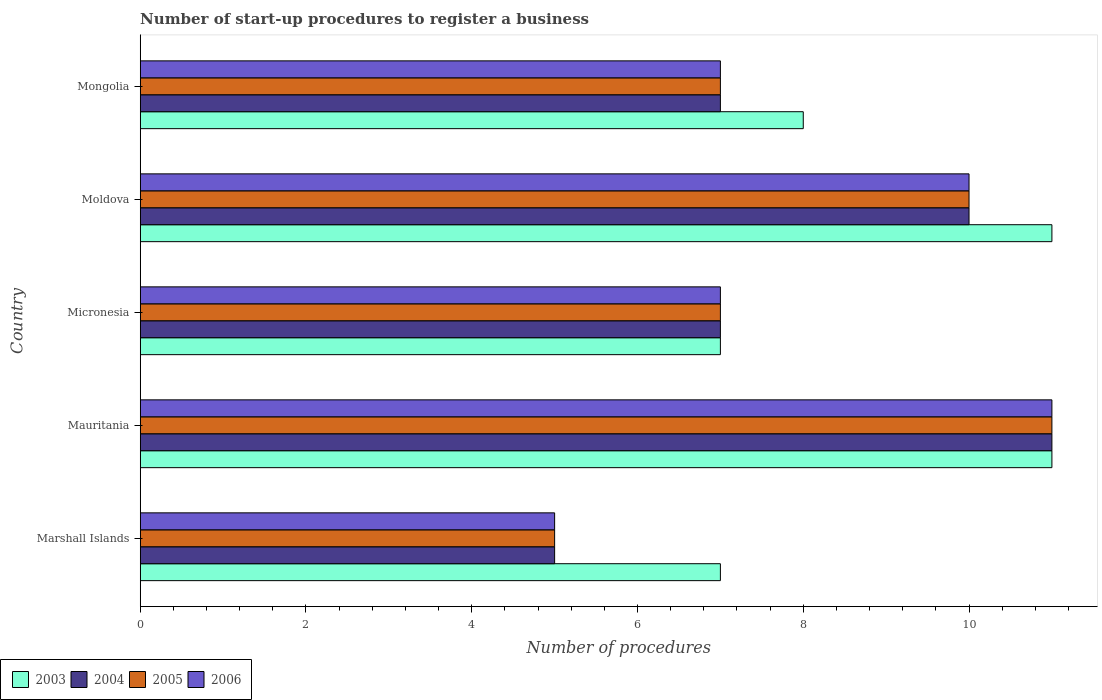How many different coloured bars are there?
Your answer should be compact. 4. Are the number of bars on each tick of the Y-axis equal?
Offer a terse response. Yes. How many bars are there on the 4th tick from the top?
Keep it short and to the point. 4. How many bars are there on the 4th tick from the bottom?
Give a very brief answer. 4. What is the label of the 1st group of bars from the top?
Ensure brevity in your answer.  Mongolia. Across all countries, what is the minimum number of procedures required to register a business in 2003?
Offer a very short reply. 7. In which country was the number of procedures required to register a business in 2005 maximum?
Provide a short and direct response. Mauritania. In which country was the number of procedures required to register a business in 2005 minimum?
Your answer should be compact. Marshall Islands. What is the difference between the number of procedures required to register a business in 2004 in Marshall Islands and that in Mongolia?
Give a very brief answer. -2. What is the difference between the number of procedures required to register a business in 2006 in Mauritania and the number of procedures required to register a business in 2005 in Marshall Islands?
Your answer should be very brief. 6. What is the difference between the number of procedures required to register a business in 2004 and number of procedures required to register a business in 2005 in Moldova?
Ensure brevity in your answer.  0. What is the ratio of the number of procedures required to register a business in 2006 in Marshall Islands to that in Mongolia?
Make the answer very short. 0.71. Is the number of procedures required to register a business in 2004 in Mauritania less than that in Moldova?
Offer a terse response. No. Is the difference between the number of procedures required to register a business in 2004 in Mauritania and Micronesia greater than the difference between the number of procedures required to register a business in 2005 in Mauritania and Micronesia?
Offer a terse response. No. What is the difference between the highest and the lowest number of procedures required to register a business in 2006?
Provide a short and direct response. 6. In how many countries, is the number of procedures required to register a business in 2003 greater than the average number of procedures required to register a business in 2003 taken over all countries?
Make the answer very short. 2. What does the 3rd bar from the top in Micronesia represents?
Offer a terse response. 2004. Is it the case that in every country, the sum of the number of procedures required to register a business in 2004 and number of procedures required to register a business in 2003 is greater than the number of procedures required to register a business in 2005?
Your answer should be compact. Yes. Are all the bars in the graph horizontal?
Ensure brevity in your answer.  Yes. How many countries are there in the graph?
Keep it short and to the point. 5. What is the difference between two consecutive major ticks on the X-axis?
Ensure brevity in your answer.  2. Does the graph contain any zero values?
Your answer should be very brief. No. Does the graph contain grids?
Keep it short and to the point. No. What is the title of the graph?
Provide a short and direct response. Number of start-up procedures to register a business. What is the label or title of the X-axis?
Your answer should be very brief. Number of procedures. What is the Number of procedures of 2005 in Marshall Islands?
Give a very brief answer. 5. What is the Number of procedures in 2003 in Mauritania?
Give a very brief answer. 11. What is the Number of procedures in 2006 in Micronesia?
Provide a short and direct response. 7. What is the Number of procedures in 2005 in Moldova?
Offer a terse response. 10. What is the Number of procedures in 2006 in Moldova?
Offer a terse response. 10. Across all countries, what is the maximum Number of procedures of 2003?
Give a very brief answer. 11. Across all countries, what is the maximum Number of procedures of 2004?
Your response must be concise. 11. Across all countries, what is the minimum Number of procedures of 2006?
Make the answer very short. 5. What is the difference between the Number of procedures of 2003 in Marshall Islands and that in Mauritania?
Keep it short and to the point. -4. What is the difference between the Number of procedures of 2004 in Marshall Islands and that in Mauritania?
Provide a short and direct response. -6. What is the difference between the Number of procedures in 2005 in Marshall Islands and that in Mauritania?
Your answer should be very brief. -6. What is the difference between the Number of procedures in 2006 in Marshall Islands and that in Mauritania?
Keep it short and to the point. -6. What is the difference between the Number of procedures in 2004 in Marshall Islands and that in Micronesia?
Offer a terse response. -2. What is the difference between the Number of procedures in 2005 in Marshall Islands and that in Micronesia?
Offer a very short reply. -2. What is the difference between the Number of procedures in 2003 in Marshall Islands and that in Moldova?
Offer a very short reply. -4. What is the difference between the Number of procedures in 2005 in Marshall Islands and that in Moldova?
Your response must be concise. -5. What is the difference between the Number of procedures in 2006 in Marshall Islands and that in Moldova?
Give a very brief answer. -5. What is the difference between the Number of procedures in 2003 in Marshall Islands and that in Mongolia?
Ensure brevity in your answer.  -1. What is the difference between the Number of procedures of 2006 in Marshall Islands and that in Mongolia?
Give a very brief answer. -2. What is the difference between the Number of procedures in 2003 in Mauritania and that in Micronesia?
Offer a very short reply. 4. What is the difference between the Number of procedures in 2004 in Mauritania and that in Micronesia?
Your answer should be very brief. 4. What is the difference between the Number of procedures of 2006 in Mauritania and that in Micronesia?
Ensure brevity in your answer.  4. What is the difference between the Number of procedures of 2003 in Mauritania and that in Moldova?
Your answer should be very brief. 0. What is the difference between the Number of procedures in 2004 in Mauritania and that in Moldova?
Your answer should be compact. 1. What is the difference between the Number of procedures of 2005 in Mauritania and that in Mongolia?
Offer a very short reply. 4. What is the difference between the Number of procedures of 2006 in Mauritania and that in Mongolia?
Give a very brief answer. 4. What is the difference between the Number of procedures of 2004 in Micronesia and that in Moldova?
Offer a terse response. -3. What is the difference between the Number of procedures in 2006 in Micronesia and that in Moldova?
Give a very brief answer. -3. What is the difference between the Number of procedures in 2004 in Micronesia and that in Mongolia?
Provide a succinct answer. 0. What is the difference between the Number of procedures of 2005 in Micronesia and that in Mongolia?
Provide a short and direct response. 0. What is the difference between the Number of procedures of 2003 in Moldova and that in Mongolia?
Give a very brief answer. 3. What is the difference between the Number of procedures of 2005 in Moldova and that in Mongolia?
Provide a succinct answer. 3. What is the difference between the Number of procedures of 2003 in Marshall Islands and the Number of procedures of 2004 in Mauritania?
Ensure brevity in your answer.  -4. What is the difference between the Number of procedures in 2003 in Marshall Islands and the Number of procedures in 2005 in Mauritania?
Give a very brief answer. -4. What is the difference between the Number of procedures of 2003 in Marshall Islands and the Number of procedures of 2006 in Mauritania?
Your response must be concise. -4. What is the difference between the Number of procedures of 2004 in Marshall Islands and the Number of procedures of 2005 in Mauritania?
Make the answer very short. -6. What is the difference between the Number of procedures in 2004 in Marshall Islands and the Number of procedures in 2006 in Mauritania?
Provide a short and direct response. -6. What is the difference between the Number of procedures of 2003 in Marshall Islands and the Number of procedures of 2004 in Micronesia?
Ensure brevity in your answer.  0. What is the difference between the Number of procedures in 2003 in Marshall Islands and the Number of procedures in 2005 in Micronesia?
Offer a terse response. 0. What is the difference between the Number of procedures in 2004 in Marshall Islands and the Number of procedures in 2005 in Micronesia?
Offer a very short reply. -2. What is the difference between the Number of procedures in 2005 in Marshall Islands and the Number of procedures in 2006 in Micronesia?
Offer a very short reply. -2. What is the difference between the Number of procedures of 2003 in Marshall Islands and the Number of procedures of 2005 in Moldova?
Offer a very short reply. -3. What is the difference between the Number of procedures in 2005 in Marshall Islands and the Number of procedures in 2006 in Moldova?
Your answer should be compact. -5. What is the difference between the Number of procedures of 2003 in Marshall Islands and the Number of procedures of 2004 in Mongolia?
Offer a terse response. 0. What is the difference between the Number of procedures of 2003 in Mauritania and the Number of procedures of 2006 in Micronesia?
Your answer should be very brief. 4. What is the difference between the Number of procedures in 2004 in Mauritania and the Number of procedures in 2006 in Micronesia?
Give a very brief answer. 4. What is the difference between the Number of procedures in 2003 in Mauritania and the Number of procedures in 2004 in Moldova?
Offer a very short reply. 1. What is the difference between the Number of procedures of 2003 in Mauritania and the Number of procedures of 2006 in Moldova?
Ensure brevity in your answer.  1. What is the difference between the Number of procedures of 2005 in Mauritania and the Number of procedures of 2006 in Moldova?
Your response must be concise. 1. What is the difference between the Number of procedures of 2004 in Mauritania and the Number of procedures of 2006 in Mongolia?
Your answer should be compact. 4. What is the difference between the Number of procedures of 2003 in Micronesia and the Number of procedures of 2004 in Moldova?
Your response must be concise. -3. What is the difference between the Number of procedures in 2003 in Micronesia and the Number of procedures in 2005 in Moldova?
Offer a very short reply. -3. What is the difference between the Number of procedures of 2003 in Micronesia and the Number of procedures of 2006 in Moldova?
Give a very brief answer. -3. What is the difference between the Number of procedures of 2004 in Micronesia and the Number of procedures of 2005 in Moldova?
Keep it short and to the point. -3. What is the difference between the Number of procedures of 2004 in Micronesia and the Number of procedures of 2006 in Moldova?
Ensure brevity in your answer.  -3. What is the difference between the Number of procedures of 2003 in Micronesia and the Number of procedures of 2005 in Mongolia?
Your response must be concise. 0. What is the difference between the Number of procedures of 2003 in Micronesia and the Number of procedures of 2006 in Mongolia?
Provide a short and direct response. 0. What is the difference between the Number of procedures in 2004 in Micronesia and the Number of procedures in 2005 in Mongolia?
Offer a very short reply. 0. What is the difference between the Number of procedures of 2004 in Micronesia and the Number of procedures of 2006 in Mongolia?
Your answer should be compact. 0. What is the difference between the Number of procedures in 2003 in Moldova and the Number of procedures in 2005 in Mongolia?
Offer a very short reply. 4. What is the difference between the Number of procedures in 2004 in Moldova and the Number of procedures in 2005 in Mongolia?
Your answer should be compact. 3. What is the difference between the Number of procedures in 2005 in Moldova and the Number of procedures in 2006 in Mongolia?
Your response must be concise. 3. What is the average Number of procedures in 2003 per country?
Offer a terse response. 8.8. What is the average Number of procedures in 2006 per country?
Provide a succinct answer. 8. What is the difference between the Number of procedures in 2003 and Number of procedures in 2006 in Marshall Islands?
Give a very brief answer. 2. What is the difference between the Number of procedures in 2004 and Number of procedures in 2006 in Marshall Islands?
Your answer should be very brief. 0. What is the difference between the Number of procedures of 2005 and Number of procedures of 2006 in Marshall Islands?
Provide a short and direct response. 0. What is the difference between the Number of procedures in 2003 and Number of procedures in 2006 in Mauritania?
Keep it short and to the point. 0. What is the difference between the Number of procedures in 2004 and Number of procedures in 2006 in Mauritania?
Offer a terse response. 0. What is the difference between the Number of procedures in 2003 and Number of procedures in 2005 in Micronesia?
Keep it short and to the point. 0. What is the difference between the Number of procedures of 2004 and Number of procedures of 2006 in Micronesia?
Your answer should be very brief. 0. What is the difference between the Number of procedures of 2003 and Number of procedures of 2005 in Moldova?
Your response must be concise. 1. What is the difference between the Number of procedures in 2003 and Number of procedures in 2006 in Moldova?
Your answer should be compact. 1. What is the difference between the Number of procedures in 2003 and Number of procedures in 2004 in Mongolia?
Your answer should be compact. 1. What is the difference between the Number of procedures of 2003 and Number of procedures of 2005 in Mongolia?
Your answer should be compact. 1. What is the difference between the Number of procedures in 2004 and Number of procedures in 2005 in Mongolia?
Make the answer very short. 0. What is the ratio of the Number of procedures of 2003 in Marshall Islands to that in Mauritania?
Make the answer very short. 0.64. What is the ratio of the Number of procedures in 2004 in Marshall Islands to that in Mauritania?
Offer a terse response. 0.45. What is the ratio of the Number of procedures in 2005 in Marshall Islands to that in Mauritania?
Your response must be concise. 0.45. What is the ratio of the Number of procedures in 2006 in Marshall Islands to that in Mauritania?
Give a very brief answer. 0.45. What is the ratio of the Number of procedures of 2003 in Marshall Islands to that in Micronesia?
Your answer should be very brief. 1. What is the ratio of the Number of procedures of 2004 in Marshall Islands to that in Micronesia?
Keep it short and to the point. 0.71. What is the ratio of the Number of procedures in 2006 in Marshall Islands to that in Micronesia?
Your answer should be very brief. 0.71. What is the ratio of the Number of procedures in 2003 in Marshall Islands to that in Moldova?
Offer a very short reply. 0.64. What is the ratio of the Number of procedures of 2004 in Marshall Islands to that in Moldova?
Your answer should be very brief. 0.5. What is the ratio of the Number of procedures of 2005 in Marshall Islands to that in Moldova?
Your response must be concise. 0.5. What is the ratio of the Number of procedures in 2006 in Marshall Islands to that in Moldova?
Make the answer very short. 0.5. What is the ratio of the Number of procedures in 2005 in Marshall Islands to that in Mongolia?
Ensure brevity in your answer.  0.71. What is the ratio of the Number of procedures in 2006 in Marshall Islands to that in Mongolia?
Your answer should be compact. 0.71. What is the ratio of the Number of procedures in 2003 in Mauritania to that in Micronesia?
Keep it short and to the point. 1.57. What is the ratio of the Number of procedures of 2004 in Mauritania to that in Micronesia?
Provide a short and direct response. 1.57. What is the ratio of the Number of procedures of 2005 in Mauritania to that in Micronesia?
Offer a terse response. 1.57. What is the ratio of the Number of procedures in 2006 in Mauritania to that in Micronesia?
Ensure brevity in your answer.  1.57. What is the ratio of the Number of procedures in 2003 in Mauritania to that in Moldova?
Offer a very short reply. 1. What is the ratio of the Number of procedures of 2005 in Mauritania to that in Moldova?
Make the answer very short. 1.1. What is the ratio of the Number of procedures of 2006 in Mauritania to that in Moldova?
Make the answer very short. 1.1. What is the ratio of the Number of procedures of 2003 in Mauritania to that in Mongolia?
Your response must be concise. 1.38. What is the ratio of the Number of procedures in 2004 in Mauritania to that in Mongolia?
Offer a terse response. 1.57. What is the ratio of the Number of procedures of 2005 in Mauritania to that in Mongolia?
Your answer should be compact. 1.57. What is the ratio of the Number of procedures of 2006 in Mauritania to that in Mongolia?
Ensure brevity in your answer.  1.57. What is the ratio of the Number of procedures in 2003 in Micronesia to that in Moldova?
Your answer should be very brief. 0.64. What is the ratio of the Number of procedures of 2005 in Micronesia to that in Moldova?
Make the answer very short. 0.7. What is the ratio of the Number of procedures in 2003 in Micronesia to that in Mongolia?
Your answer should be very brief. 0.88. What is the ratio of the Number of procedures of 2004 in Micronesia to that in Mongolia?
Keep it short and to the point. 1. What is the ratio of the Number of procedures of 2003 in Moldova to that in Mongolia?
Offer a very short reply. 1.38. What is the ratio of the Number of procedures in 2004 in Moldova to that in Mongolia?
Offer a terse response. 1.43. What is the ratio of the Number of procedures in 2005 in Moldova to that in Mongolia?
Provide a succinct answer. 1.43. What is the ratio of the Number of procedures of 2006 in Moldova to that in Mongolia?
Offer a very short reply. 1.43. What is the difference between the highest and the second highest Number of procedures in 2003?
Give a very brief answer. 0. What is the difference between the highest and the second highest Number of procedures in 2004?
Offer a very short reply. 1. What is the difference between the highest and the second highest Number of procedures in 2006?
Make the answer very short. 1. What is the difference between the highest and the lowest Number of procedures of 2004?
Provide a short and direct response. 6. What is the difference between the highest and the lowest Number of procedures in 2005?
Provide a succinct answer. 6. 